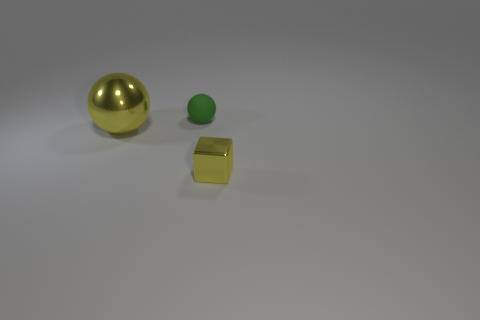Add 1 large blue cylinders. How many objects exist? 4 Subtract all spheres. How many objects are left? 1 Subtract all green things. Subtract all matte objects. How many objects are left? 1 Add 1 big balls. How many big balls are left? 2 Add 1 tiny yellow matte cubes. How many tiny yellow matte cubes exist? 1 Subtract 0 red cubes. How many objects are left? 3 